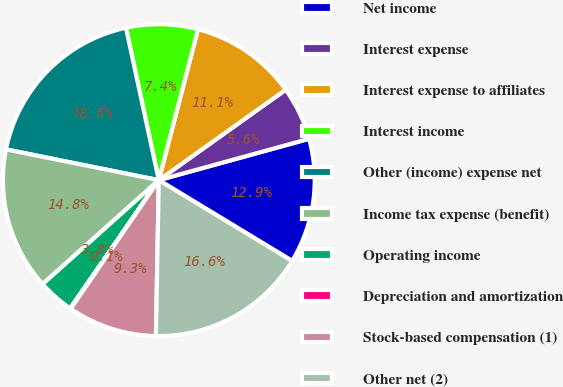Convert chart to OTSL. <chart><loc_0><loc_0><loc_500><loc_500><pie_chart><fcel>Net income<fcel>Interest expense<fcel>Interest expense to affiliates<fcel>Interest income<fcel>Other (income) expense net<fcel>Income tax expense (benefit)<fcel>Operating income<fcel>Depreciation and amortization<fcel>Stock-based compensation (1)<fcel>Other net (2)<nl><fcel>12.94%<fcel>5.58%<fcel>11.1%<fcel>7.42%<fcel>18.46%<fcel>14.78%<fcel>3.75%<fcel>0.07%<fcel>9.26%<fcel>16.62%<nl></chart> 